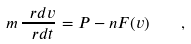<formula> <loc_0><loc_0><loc_500><loc_500>m \, \frac { \ r d v } { \ r d t } = P - n F ( v ) \quad ,</formula> 